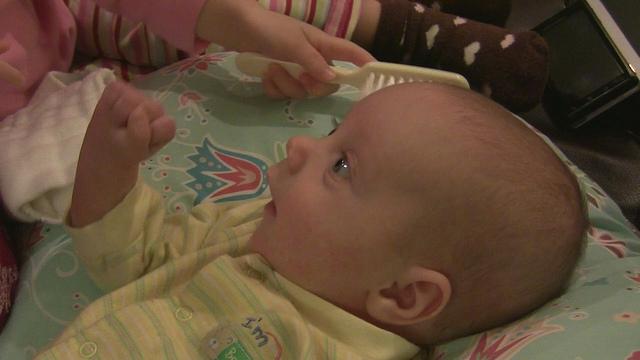How relaxed do I look at this moment?
Concise answer only. Very. What color outfit is the baby wearing?
Short answer required. Yellow. What is she wearing around her neck?
Be succinct. Nothing. What color appears on the item above the baby's head?
Concise answer only. Brown. Does the baby have long eyelashes?
Short answer required. Yes. What protects the baby's clothes from getting stained with food?
Answer briefly. Bib. What color is the baby's shirt?
Concise answer only. Yellow. How old is this baby?
Be succinct. 2 months. What is the red object on the pillow case?
Short answer required. Flower. What color is the comb?
Keep it brief. White. What is the baby laying on?
Give a very brief answer. Pillow. Is this kid sleeping?
Short answer required. No. Is the child bald?
Write a very short answer. No. Does this baby look surprised?
Concise answer only. Yes. Is the child sleeping?
Write a very short answer. No. What is this child touching?
Give a very brief answer. Nothing. What is green in the picture?
Be succinct. Pillow. Does the baby have a free hand?
Answer briefly. Yes. 